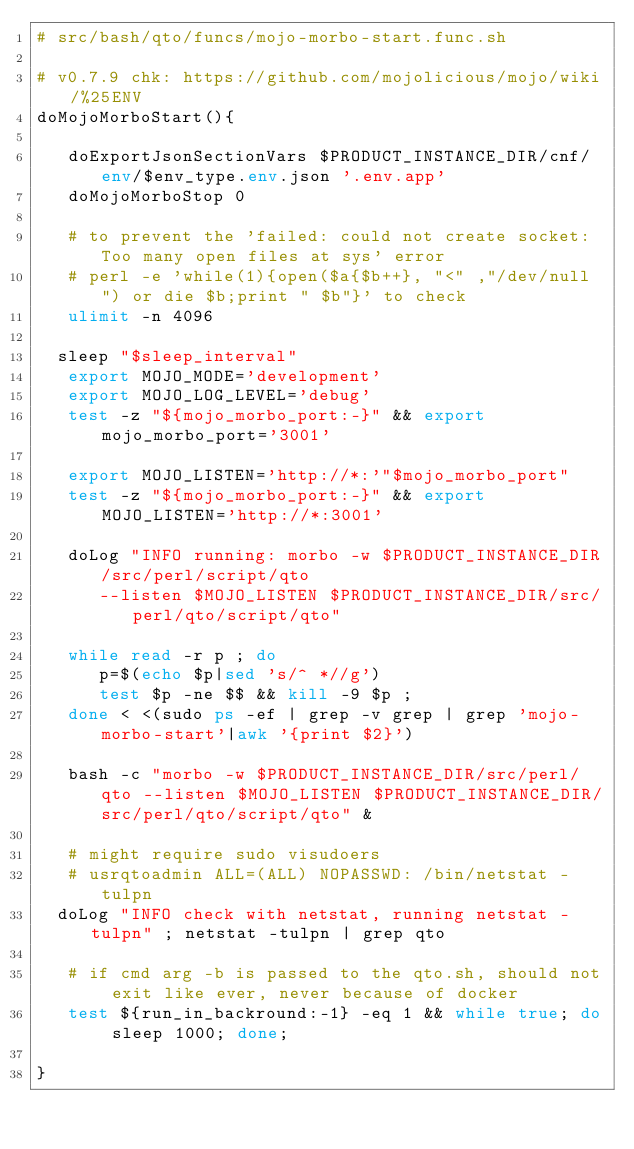Convert code to text. <code><loc_0><loc_0><loc_500><loc_500><_Bash_># src/bash/qto/funcs/mojo-morbo-start.func.sh

# v0.7.9 chk: https://github.com/mojolicious/mojo/wiki/%25ENV
doMojoMorboStart(){

   doExportJsonSectionVars $PRODUCT_INSTANCE_DIR/cnf/env/$env_type.env.json '.env.app'
   doMojoMorboStop 0
   
   # to prevent the 'failed: could not create socket: Too many open files at sys' error
   # perl -e 'while(1){open($a{$b++}, "<" ,"/dev/null") or die $b;print " $b"}' to check
   ulimit -n 4096

	sleep "$sleep_interval"
   export MOJO_MODE='development'
   export MOJO_LOG_LEVEL='debug'
   test -z "${mojo_morbo_port:-}" && export mojo_morbo_port='3001'

   export MOJO_LISTEN='http://*:'"$mojo_morbo_port"
   test -z "${mojo_morbo_port:-}" && export MOJO_LISTEN='http://*:3001'
   
   doLog "INFO running: morbo -w $PRODUCT_INSTANCE_DIR/src/perl/script/qto
      --listen $MOJO_LISTEN $PRODUCT_INSTANCE_DIR/src/perl/qto/script/qto"

   while read -r p ; do 
      p=$(echo $p|sed 's/^ *//g')
      test $p -ne $$ && kill -9 $p ; 
   done < <(sudo ps -ef | grep -v grep | grep 'mojo-morbo-start'|awk '{print $2}')

   bash -c "morbo -w $PRODUCT_INSTANCE_DIR/src/perl/qto --listen $MOJO_LISTEN $PRODUCT_INSTANCE_DIR/src/perl/qto/script/qto" &

   # might require sudo visudoers 
   # usrqtoadmin ALL=(ALL) NOPASSWD: /bin/netstat -tulpn
	doLog "INFO check with netstat, running netstat -tulpn" ; netstat -tulpn | grep qto
 
   # if cmd arg -b is passed to the qto.sh, should not exit like ever, never because of docker
   test ${run_in_backround:-1} -eq 1 && while true; do sleep 1000; done;

}
</code> 